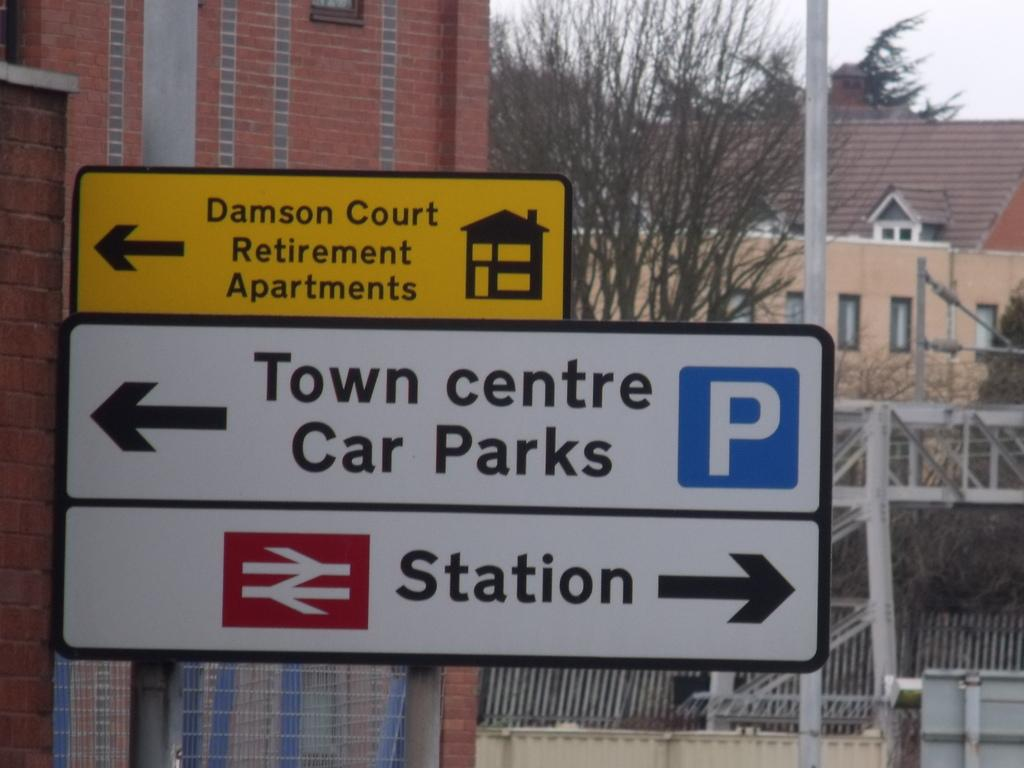<image>
Render a clear and concise summary of the photo. three street sings one says station and the other one is about the town centre parking lot. 